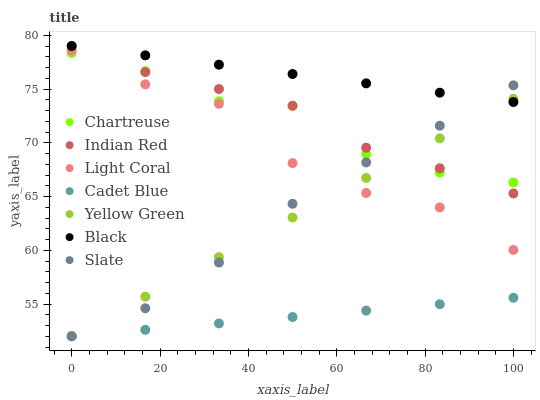Does Cadet Blue have the minimum area under the curve?
Answer yes or no. Yes. Does Black have the maximum area under the curve?
Answer yes or no. Yes. Does Yellow Green have the minimum area under the curve?
Answer yes or no. No. Does Yellow Green have the maximum area under the curve?
Answer yes or no. No. Is Cadet Blue the smoothest?
Answer yes or no. Yes. Is Light Coral the roughest?
Answer yes or no. Yes. Is Yellow Green the smoothest?
Answer yes or no. No. Is Yellow Green the roughest?
Answer yes or no. No. Does Cadet Blue have the lowest value?
Answer yes or no. Yes. Does Light Coral have the lowest value?
Answer yes or no. No. Does Indian Red have the highest value?
Answer yes or no. Yes. Does Yellow Green have the highest value?
Answer yes or no. No. Is Chartreuse less than Black?
Answer yes or no. Yes. Is Indian Red greater than Cadet Blue?
Answer yes or no. Yes. Does Yellow Green intersect Chartreuse?
Answer yes or no. Yes. Is Yellow Green less than Chartreuse?
Answer yes or no. No. Is Yellow Green greater than Chartreuse?
Answer yes or no. No. Does Chartreuse intersect Black?
Answer yes or no. No. 